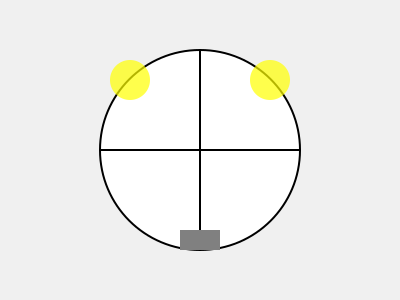Which lighting setup is most suitable for capturing accurate before and after skincare photos? To capture accurate before and after skincare photos, the lighting setup is crucial. Here's a step-by-step explanation of the ideal setup:

1. Use two light sources: This creates even illumination and reduces shadows.
2. Position lights at a 45-degree angle: This helps to highlight facial features without creating harsh shadows.
3. Place lights at eye level: This ensures balanced lighting across the face.
4. Use diffused light: Soft, diffused light helps to minimize the appearance of skin texture and provides a more flattering result.
5. Maintain consistent lighting: Use the same setup for both before and after photos to ensure accurate comparison.
6. Avoid direct overhead lighting: This can create unflattering shadows and highlight imperfections.
7. Use a neutral background: A plain, light-colored background helps focus attention on the skin.
8. Position the camera straight-on: This provides a consistent view of the face for comparison.

The diagram shows two light sources (yellow circles) positioned at 45-degree angles and at eye level relative to the subject (large circle). The rectangle at the bottom represents the camera positioned straight-on.
Answer: Two diffused lights at 45-degree angles, eye level 